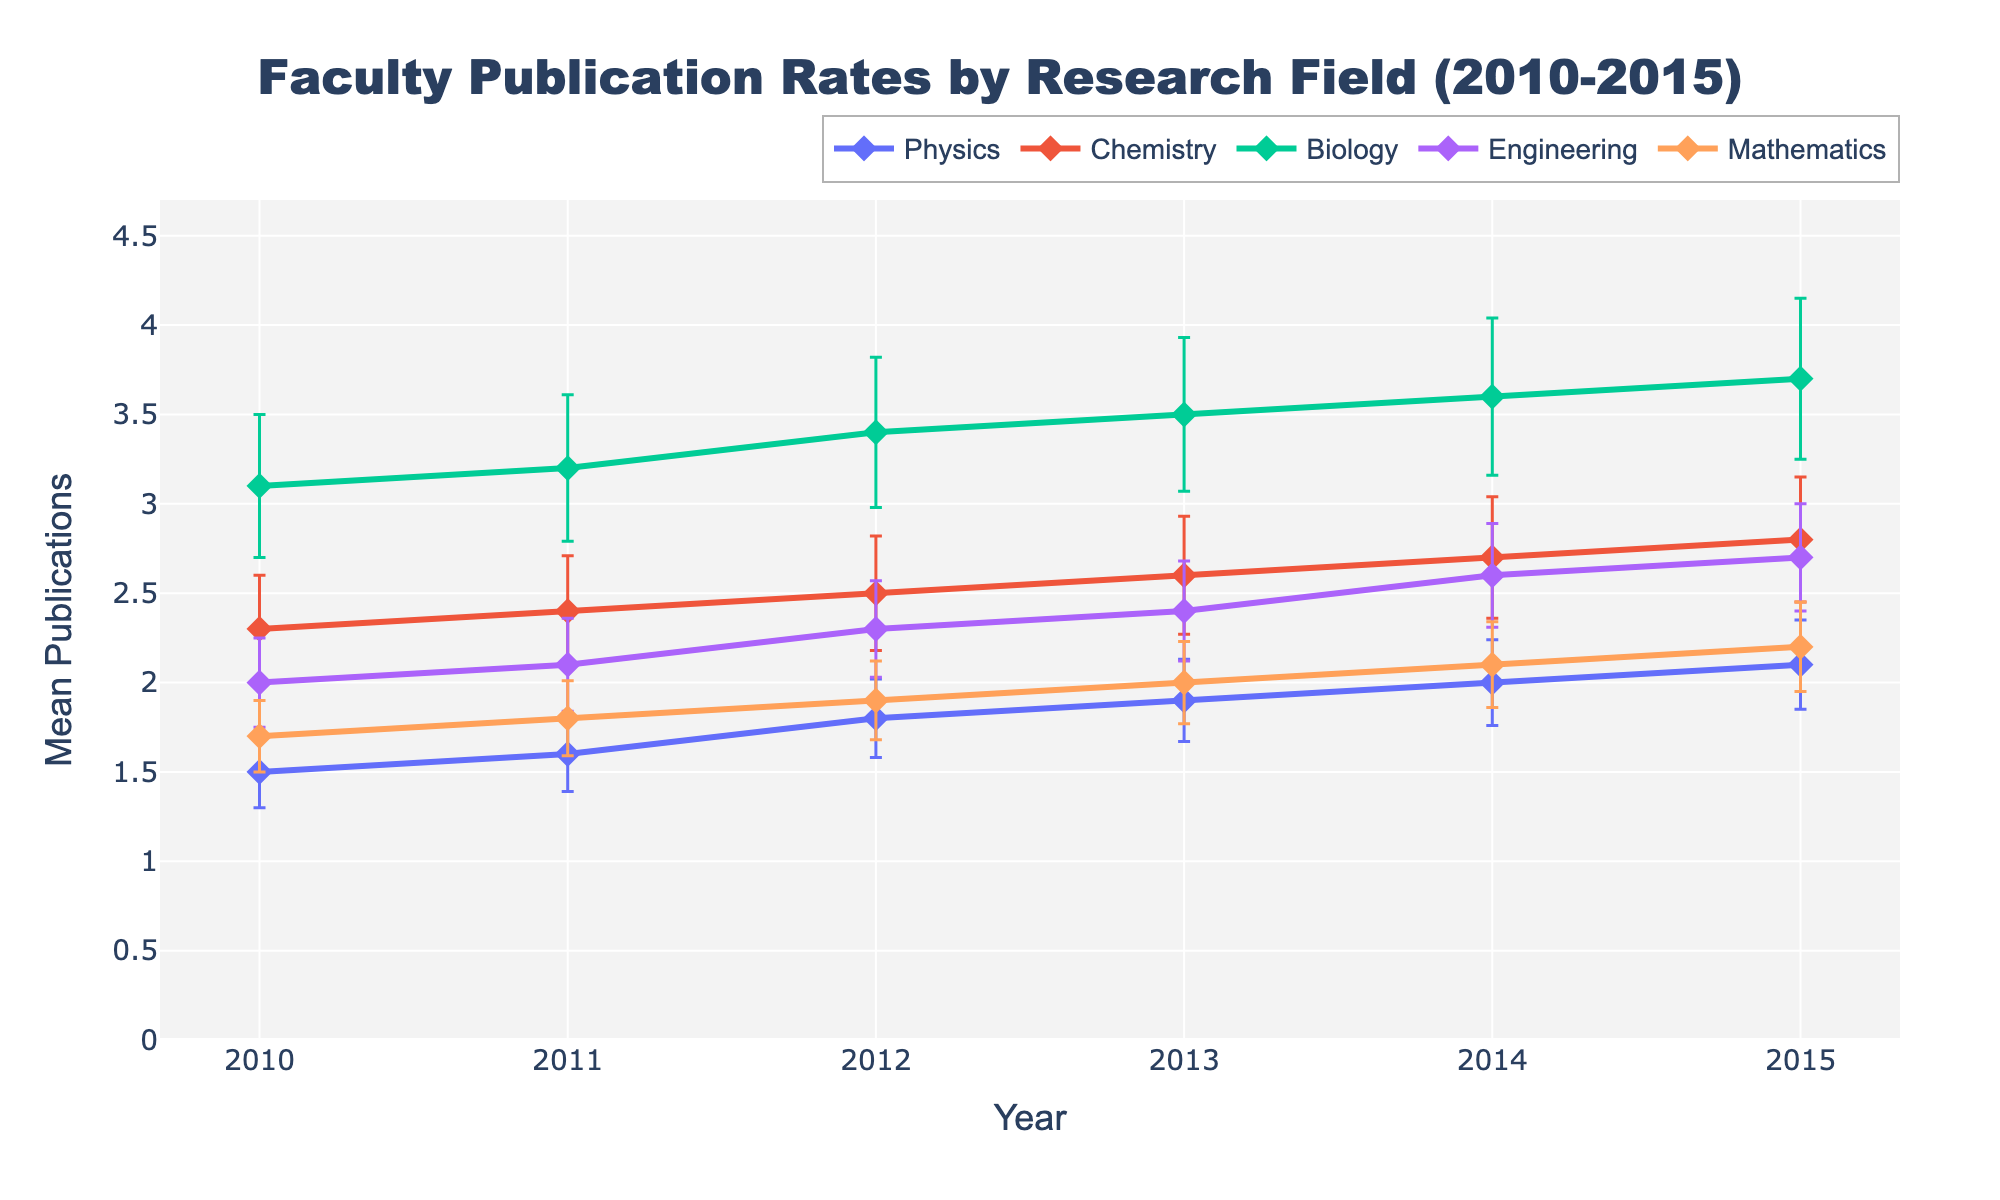What's the title of the figure? The title is provided at the top of the figure.
Answer: Faculty Publication Rates by Research Field (2010-2015) How does the publication rate of Biology in 2013 compare to that of Physics in the same year? Locate the data points for Biology and Physics in 2013 and compare their Mean Publications values. Biology has 3.5 publications, and Physics has 1.9 publications.
Answer: Biology has more publications than Physics What is the mean number of publications for Mathematics in 2010? Find the data point for Mathematics in 2010 and refer to the Mean Publications.
Answer: 1.7 Which research field shows the highest publication rate in 2015? Compare the 2015 data points for all fields to find the highest Mean Publications value.
Answer: Biology What is the difference in publication rates between Biology and Engineering in 2012? Identify the 2012 data points for Biology and Engineering, then subtract the Mean Publications of Engineering from that of Biology. Biology has 3.4 and Engineering has 2.3, so 3.4 - 2.3 = 1.1.
Answer: 1.1 What is the trend of Physics publications from 2010 to 2015? Observe the data points for Physics from 2010 to 2015 to describe how the Mean Publications change over time. The publication rate increases gradually from 1.5 to 2.1.
Answer: Increasing Which year shows the smallest error bar for Mathematics? Compare the error bars for Mathematics across all the years to find the smallest one. The smallest error bar is in 2010 with a Standard Error of 0.2.
Answer: 2010 How does the publication rate of Chemistry in 2011 compare to that of Mathematics in 2011? Locate the data points for both Chemistry and Mathematics in 2011 and compare their Mean Publications values. Chemistry has 2.4 while Mathematics has 1.8.
Answer: Chemistry has more publications than Mathematics What is the average publication rate of Physics from 2012 to 2014? Sum the Mean Publications for Physics in 2012, 2013, and 2014, then divide by 3. (1.8 + 1.9 + 2.0) / 3 = 1.9.
Answer: 1.9 Which research field has the most stable publication rate from 2010 to 2015? Evaluate the consistency of Mean Publications over the years for each field by observing the data points and error bars. Engineering shows a consistent increase with smaller error bars.
Answer: Engineering 